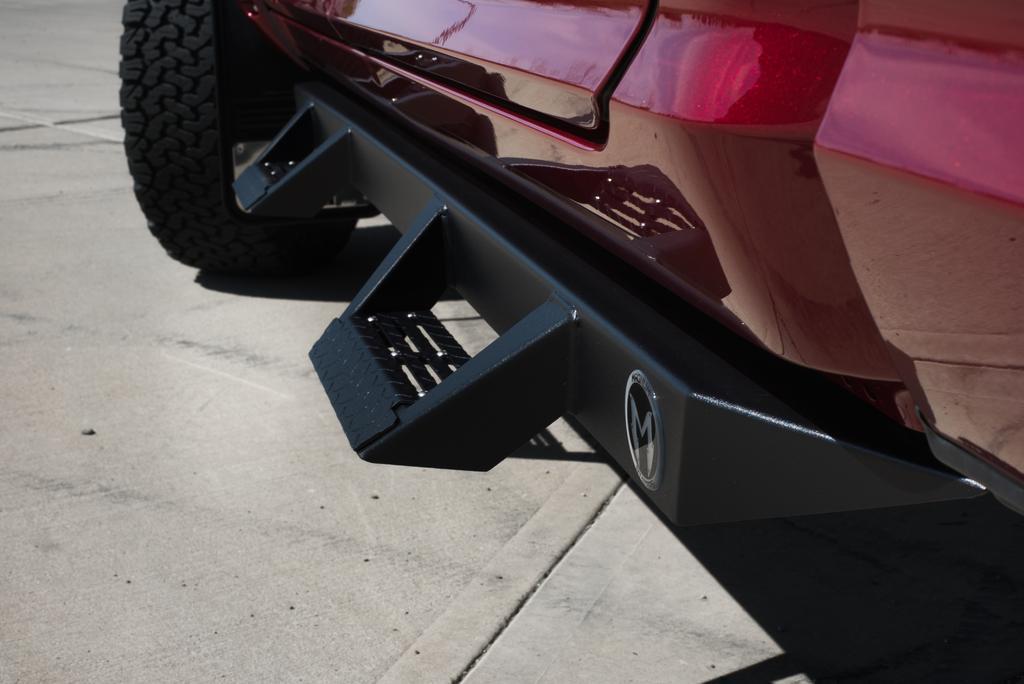Please provide a concise description of this image. In this image we can see a vehicle and we can see a bumper part of a vehicle with a black wheel on the road. 